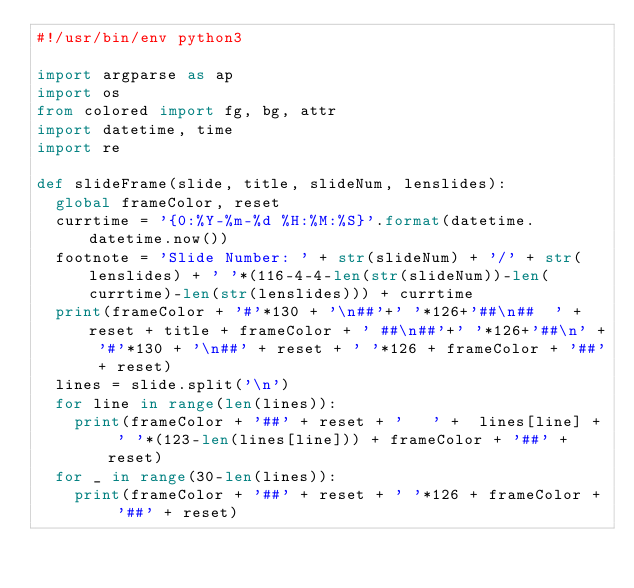Convert code to text. <code><loc_0><loc_0><loc_500><loc_500><_Python_>#!/usr/bin/env python3

import argparse as ap
import os
from colored import fg, bg, attr
import datetime, time
import re

def slideFrame(slide, title, slideNum, lenslides):
	global frameColor, reset
	currtime = '{0:%Y-%m-%d %H:%M:%S}'.format(datetime.datetime.now())
	footnote = 'Slide Number: ' + str(slideNum) + '/' + str(lenslides) + ' '*(116-4-4-len(str(slideNum))-len(currtime)-len(str(lenslides))) + currtime
	print(frameColor + '#'*130 + '\n##'+' '*126+'##\n##  ' + reset + title + frameColor + ' ##\n##'+' '*126+'##\n' + '#'*130 + '\n##' + reset + ' '*126 + frameColor + '##' + reset)
	lines = slide.split('\n')
	for line in range(len(lines)):
		print(frameColor + '##' + reset + '   ' +  lines[line] + ' '*(123-len(lines[line])) + frameColor + '##' + reset)
	for _ in range(30-len(lines)):
		print(frameColor + '##' + reset + ' '*126 + frameColor + '##' + reset)</code> 